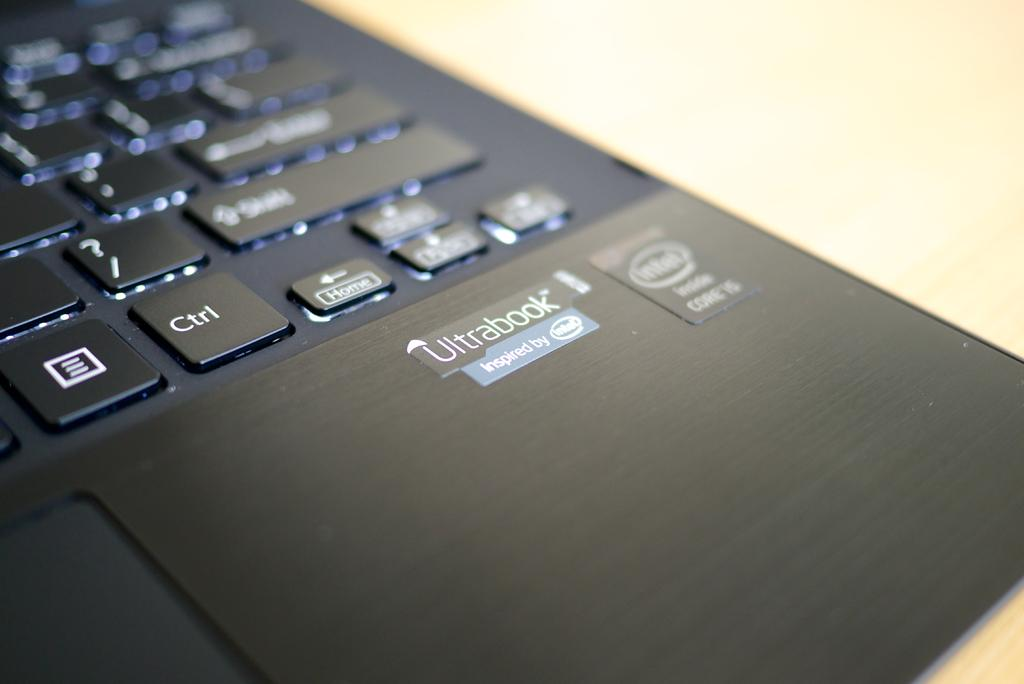<image>
Write a terse but informative summary of the picture. A sticker on a laptop claims the model is an Ultrabook. 